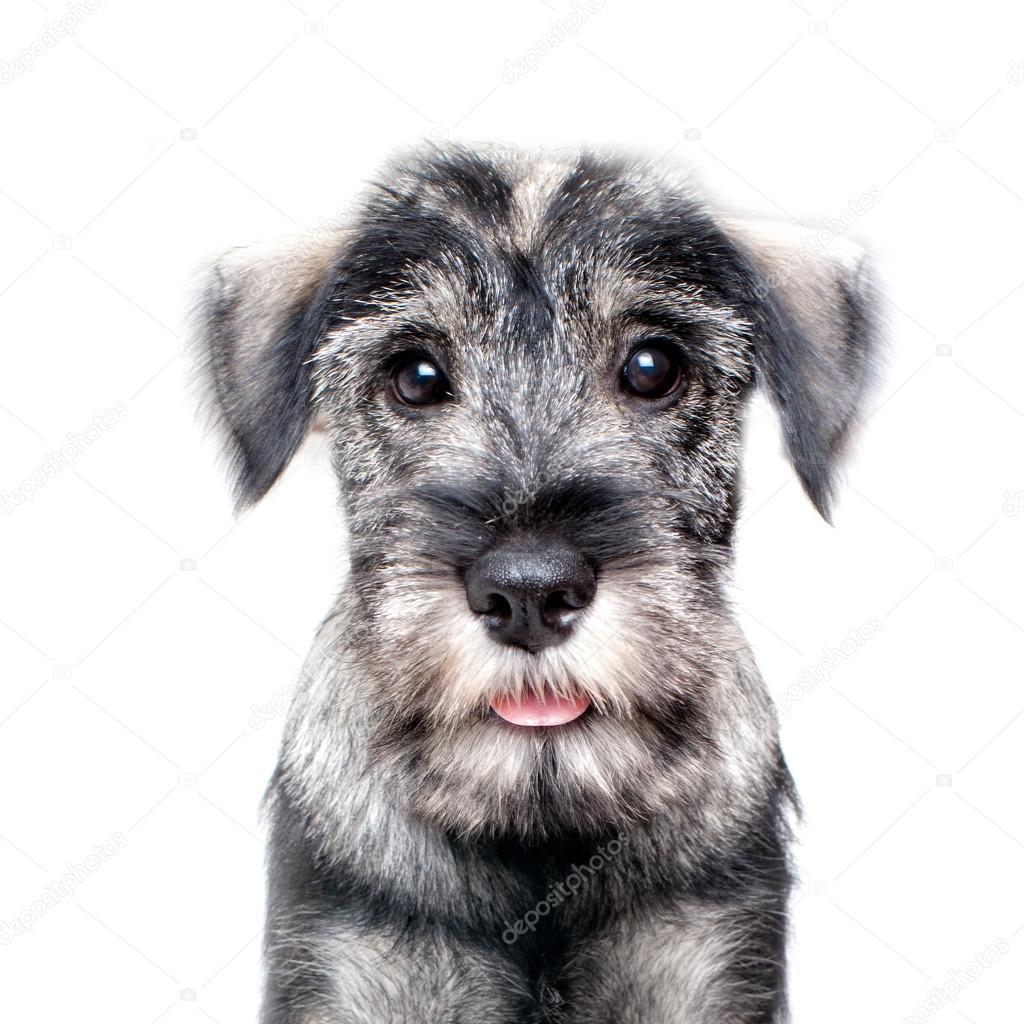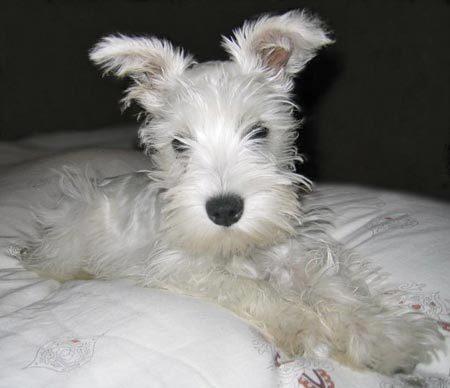The first image is the image on the left, the second image is the image on the right. Examine the images to the left and right. Is the description "The right image shows a schnauzer standing in the snow." accurate? Answer yes or no. No. 